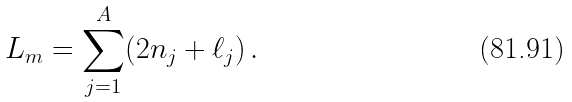Convert formula to latex. <formula><loc_0><loc_0><loc_500><loc_500>L _ { m } = \sum ^ { A } _ { j = 1 } ( 2 n _ { j } + \ell _ { j } ) \, .</formula> 